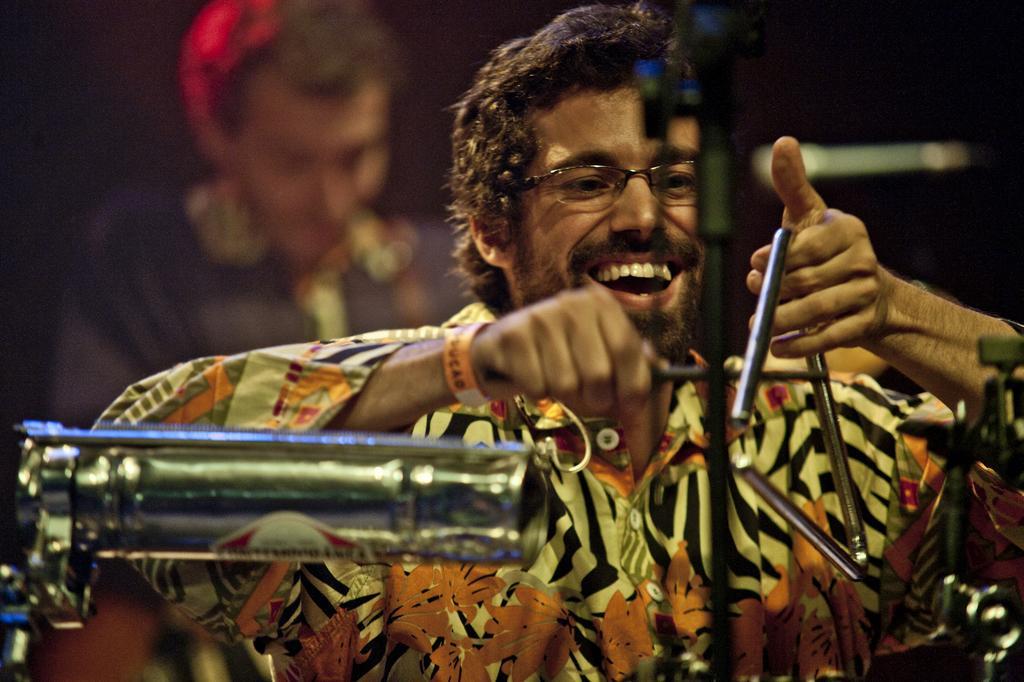Please provide a concise description of this image. In this image in the front there is a musical instrument. In the center there is a person smiling and holding object in his hand. In the background there is a person and the background seems to be blurred. 